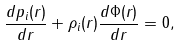<formula> <loc_0><loc_0><loc_500><loc_500>\frac { d p _ { i } ( r ) } { d r } + \rho _ { i } ( r ) \frac { d \Phi ( r ) } { d r } = 0 ,</formula> 